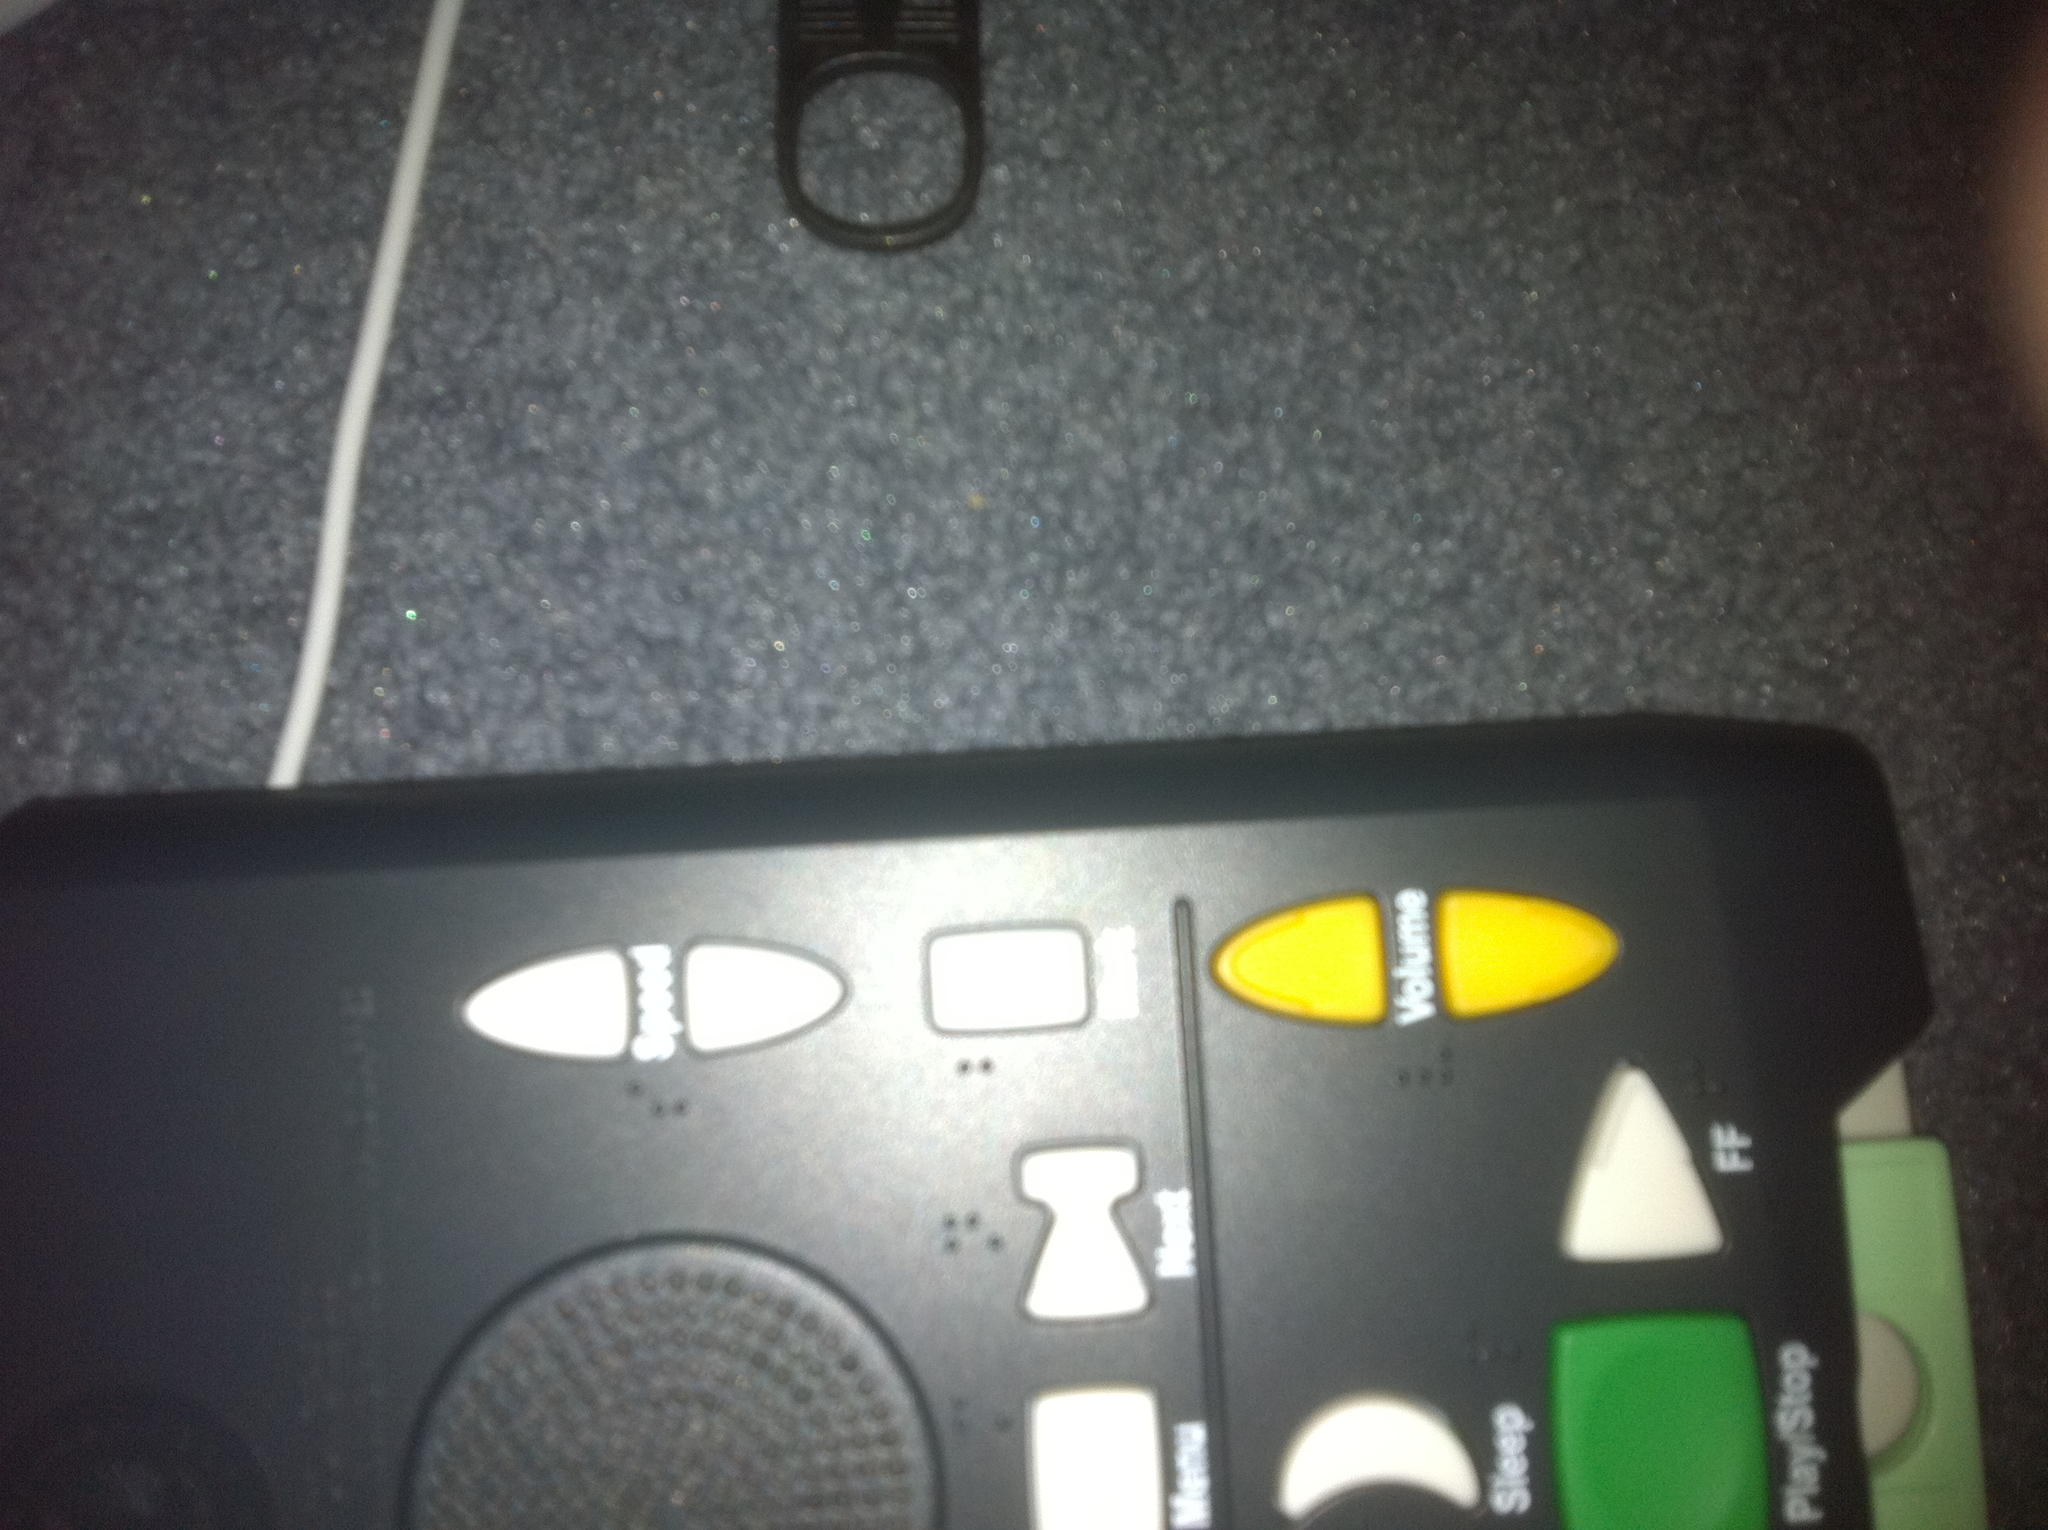What is this item and what color is it? The item in the image is a black remote control, prominently featuring various functional buttons like 'speed', 'menu', and 'volume', which are colored in white and yellow for easy recognition. 